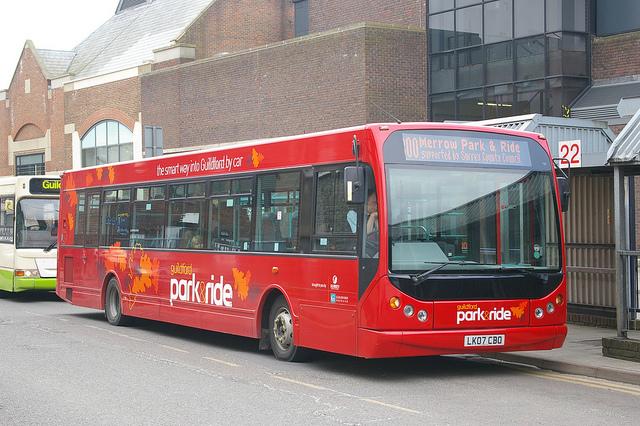What double letter is on the side of the bus?
Be succinct. R. What is the color of the bus?
Be succinct. Red. On what side of the bus is the driver seated?
Answer briefly. Right. Is the bus a double-decker?
Give a very brief answer. No. Is the bus for private charter or public transportation?
Keep it brief. Public. Is this a special made bus?
Short answer required. No. What is written on the side of the bus?
Answer briefly. Park ride. 